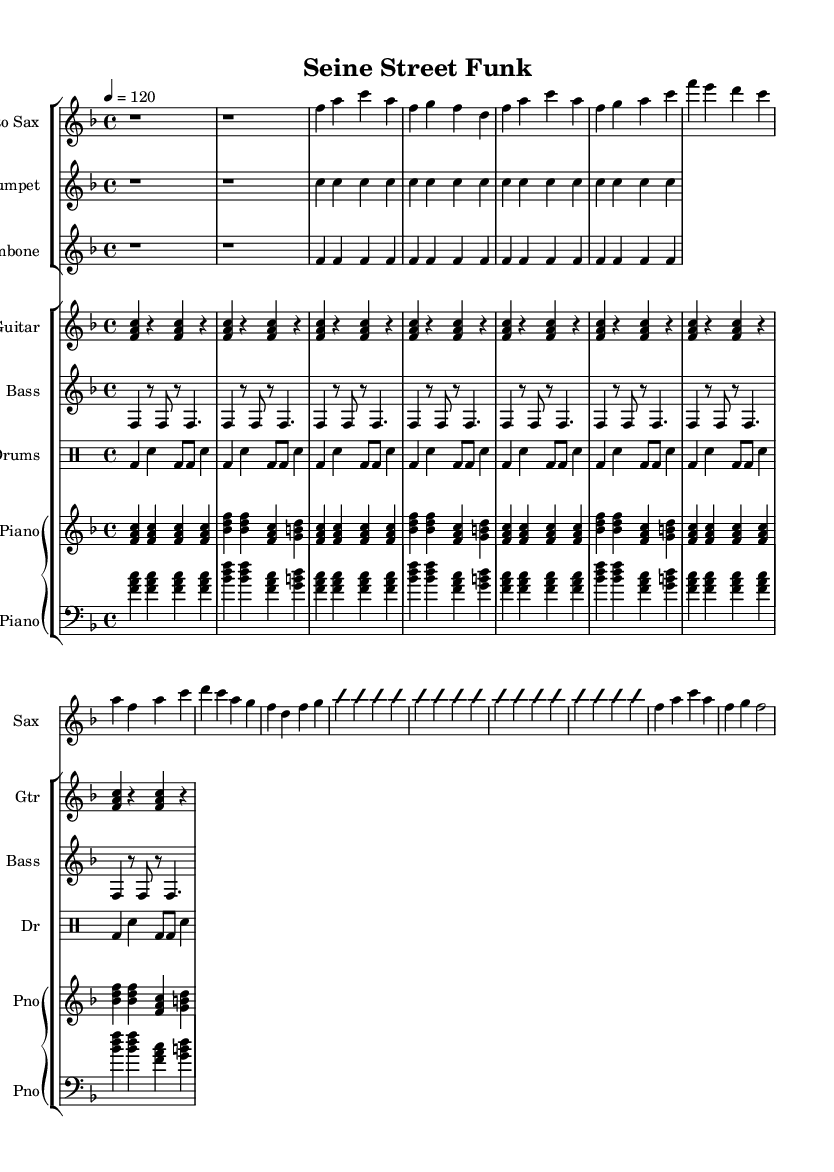What is the key signature of this music? The key signature is F major, which has one flat (B flat). This can be identified in the beginning of the treble clef staff where the flat is indicated.
Answer: F major What is the time signature of this music? The time signature is 4/4, which means there are four beats in each measure and the quarter note gets one beat. This is denoted at the beginning of the score.
Answer: 4/4 What is the tempo marking for this piece? The tempo marking is 120 beats per minute, indicated above the staff. This gives the performer a guide to the speed of the piece.
Answer: 120 Which instrument has an improvisation section? The improvisation section is indicated by the phrases "improvisationOn" and "improvisationOff" in the saxophone part, suggesting this part allows for creative expression without a strict melody.
Answer: Saxophone What type of drum pattern is used in this piece? The drum pattern is a second line beat, typical in New Orleans funk. It consists of bass drum and snare patterns that create a distinctive groove.
Answer: Second line beat How many instruments are part of the ensemble in this piece? The score contains a total of seven instruments including saxophone, trumpet, trombone, guitar, bass, drums, and piano. This can be counted from the staff groups in the score layout.
Answer: Seven What is the last note of the saxophone part? The last note of the saxophone part is G, as indicated in the last measure of the part where the note is clearly marked.
Answer: G 